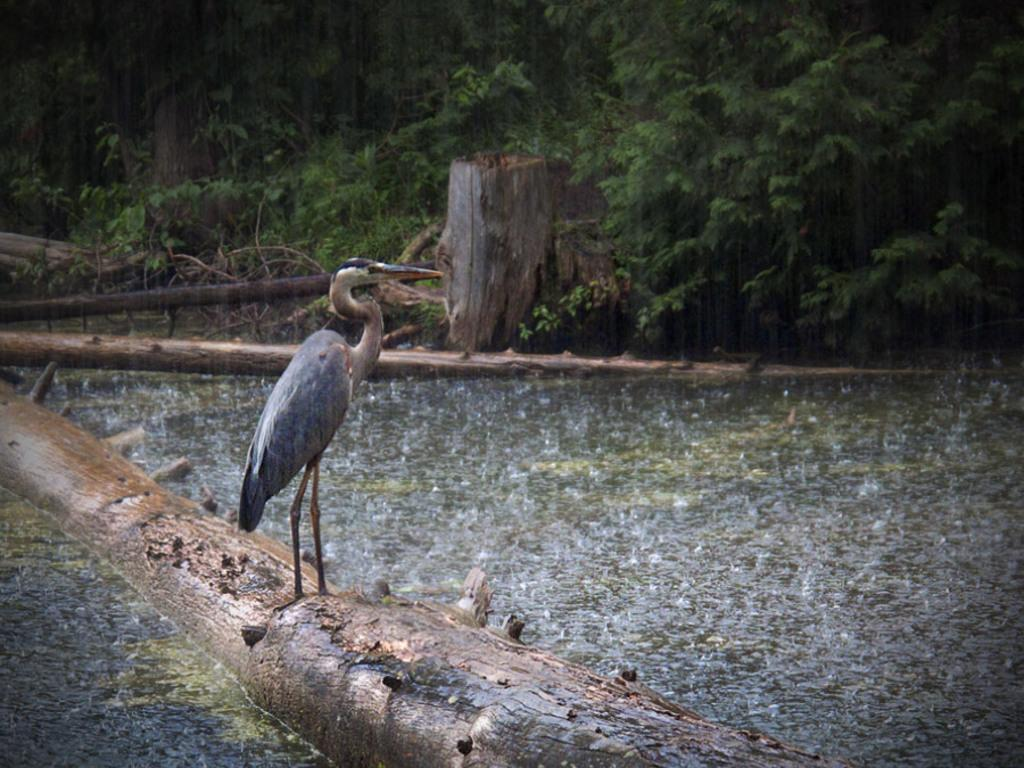What is the main subject in the foreground of the image? There is a crane in the foreground of the image. Where is the crane standing? The crane is standing on a trunk in the water. What can be seen in the background of the image? There are trees visible in the background of the image. What else can be observed in the background? A trunk has fallen down to the ground in the background. What type of toys are scattered around the crane in the image? There are no toys present in the image; it features a crane standing on a trunk in the water with trees in the background. 